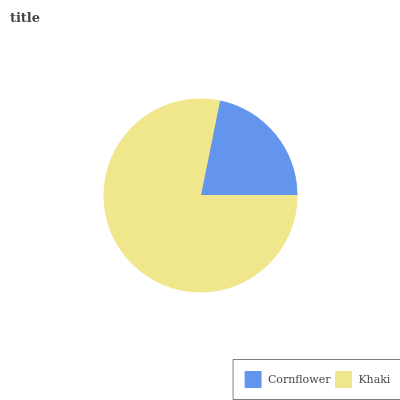Is Cornflower the minimum?
Answer yes or no. Yes. Is Khaki the maximum?
Answer yes or no. Yes. Is Khaki the minimum?
Answer yes or no. No. Is Khaki greater than Cornflower?
Answer yes or no. Yes. Is Cornflower less than Khaki?
Answer yes or no. Yes. Is Cornflower greater than Khaki?
Answer yes or no. No. Is Khaki less than Cornflower?
Answer yes or no. No. Is Khaki the high median?
Answer yes or no. Yes. Is Cornflower the low median?
Answer yes or no. Yes. Is Cornflower the high median?
Answer yes or no. No. Is Khaki the low median?
Answer yes or no. No. 